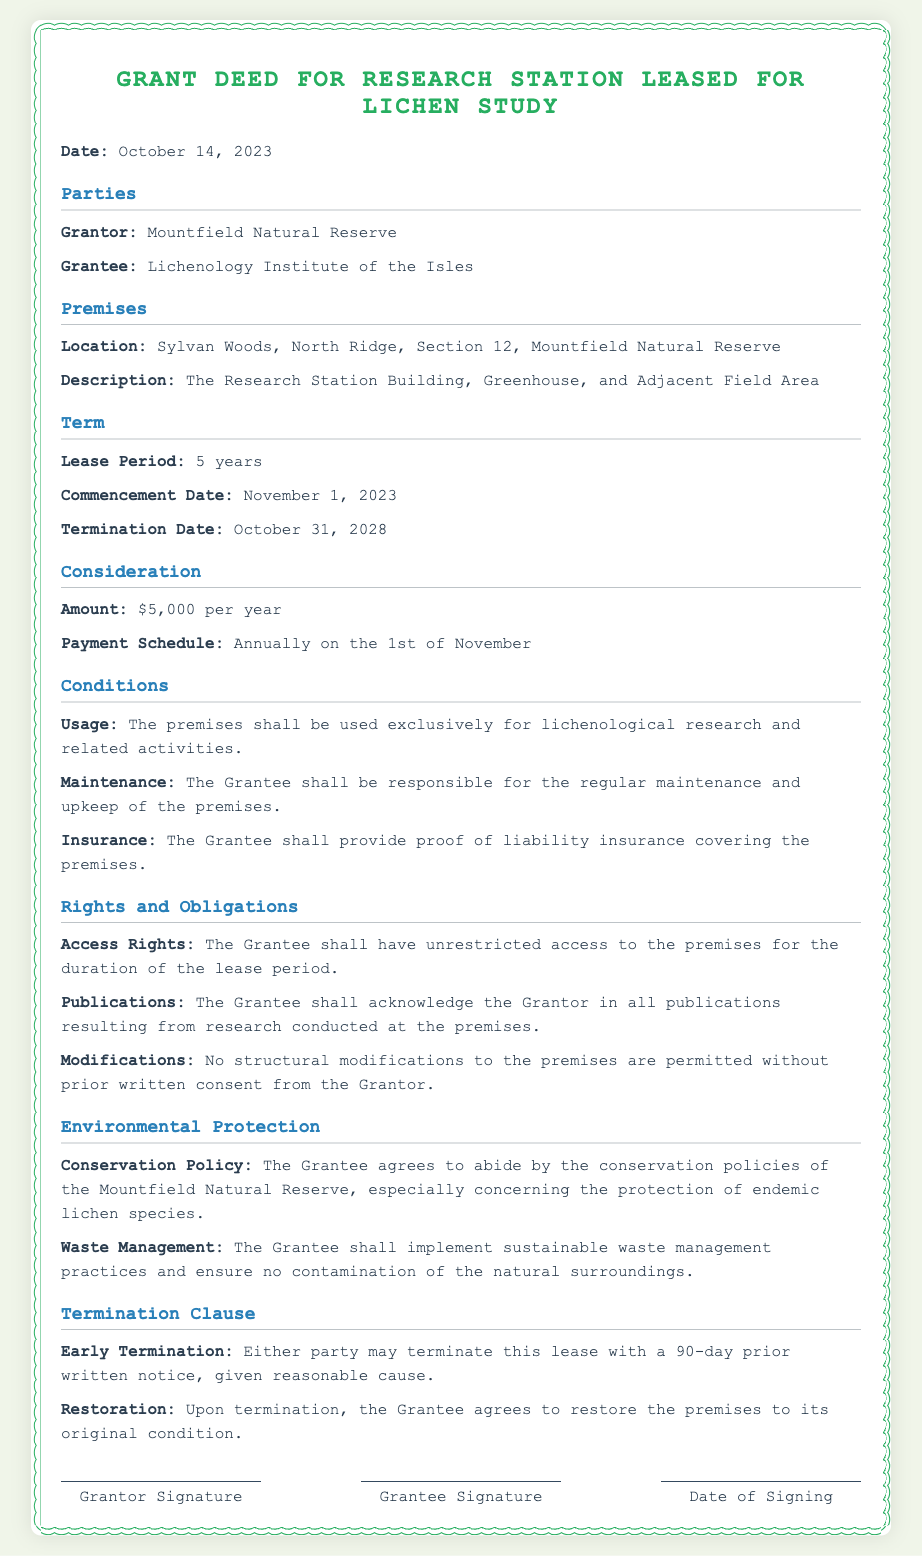What is the grantor's name? The grantor is named in the document as the entity providing the lease.
Answer: Mountfield Natural Reserve What is the location of the premises? The location describes where the leased research station is situated.
Answer: Sylvan Woods, North Ridge, Section 12, Mountfield Natural Reserve What is the lease period? The lease period indicates the duration for which the lease is valid.
Answer: 5 years What is the annual amount for the lease? The amount outlines how much the grantee needs to pay each year for the lease.
Answer: $5,000 per year What is the commencement date of the lease? The commencement date specifies when the lease officially starts.
Answer: November 1, 2023 What must the grantee do for maintenance? The maintenance responsibility outlines what the grantee is obliged to do regarding the premises.
Answer: Regular maintenance and upkeep What must the grantee provide proof of? This question pertains to a requirement imposed on the grantee in relation to the premises.
Answer: Liability insurance What can trigger early termination of the lease? This question asks for the condition under which the lease can be terminated before its completion.
Answer: Reasonable cause What is the restoration obligation upon termination? This outlines what the grantee must do concerning the premises when the lease ends.
Answer: Restore the premises to its original condition 